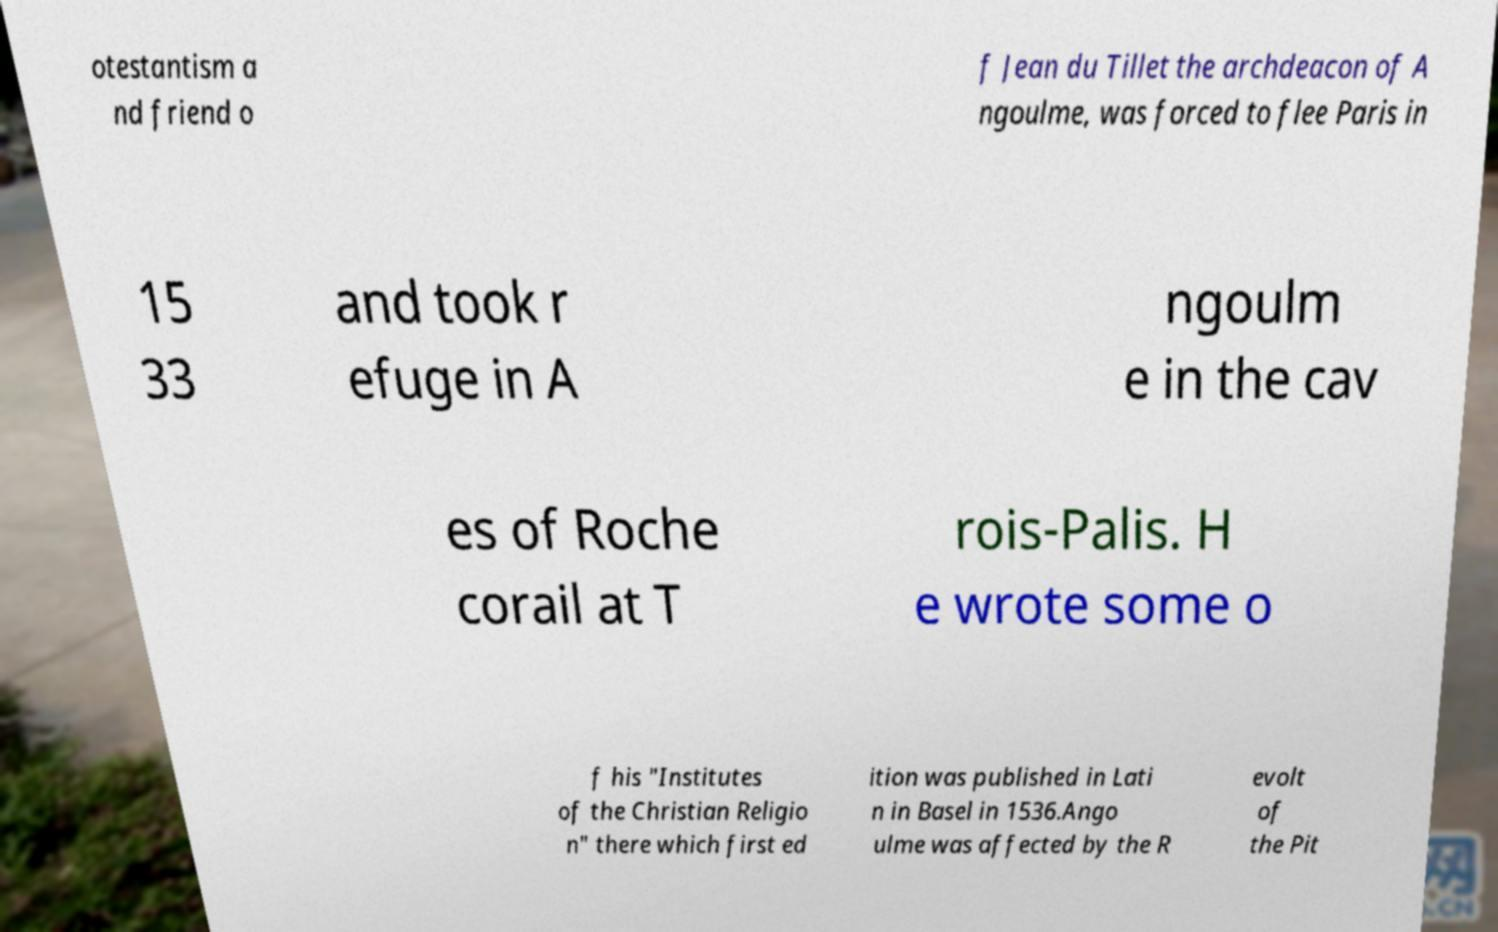Could you extract and type out the text from this image? otestantism a nd friend o f Jean du Tillet the archdeacon of A ngoulme, was forced to flee Paris in 15 33 and took r efuge in A ngoulm e in the cav es of Roche corail at T rois-Palis. H e wrote some o f his "Institutes of the Christian Religio n" there which first ed ition was published in Lati n in Basel in 1536.Ango ulme was affected by the R evolt of the Pit 